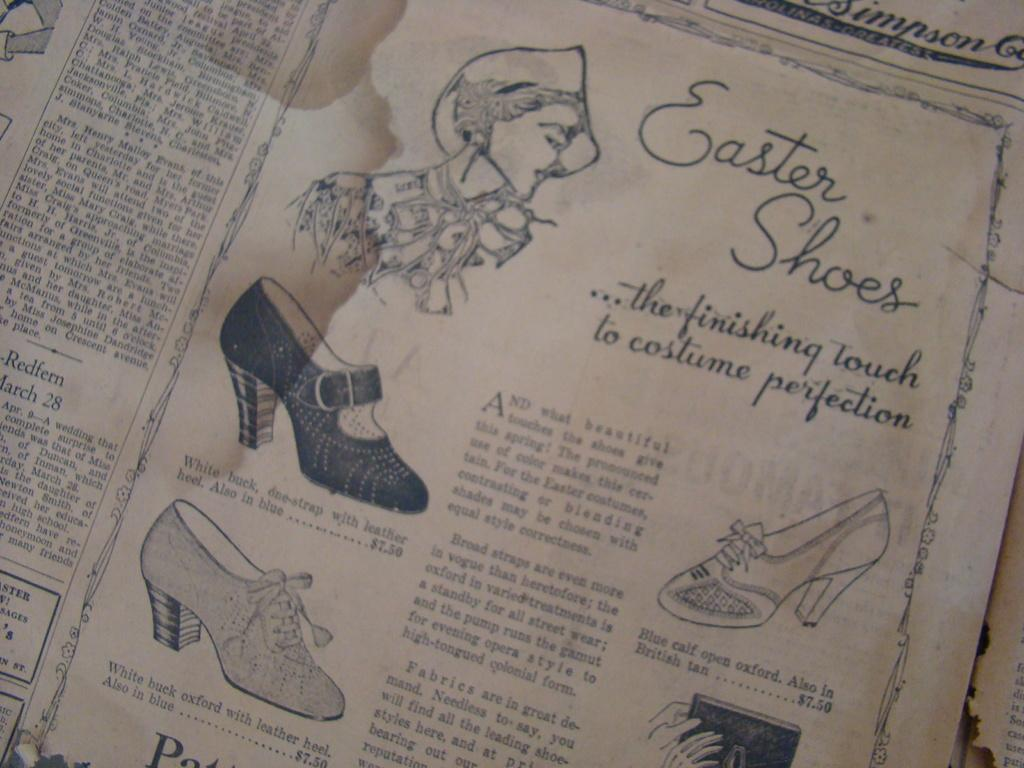What is the main object in the image? The image contains a paper. What can be found on the paper? There are pictures and letters on the paper. Can you see a knife being used to cut the paper in the image? There is no knife present in the image, and the paper is not being cut. 